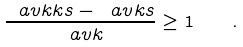Convert formula to latex. <formula><loc_0><loc_0><loc_500><loc_500>\frac { \ a v k k s - \ a v k s } { \ a v k } \geq 1 \quad .</formula> 